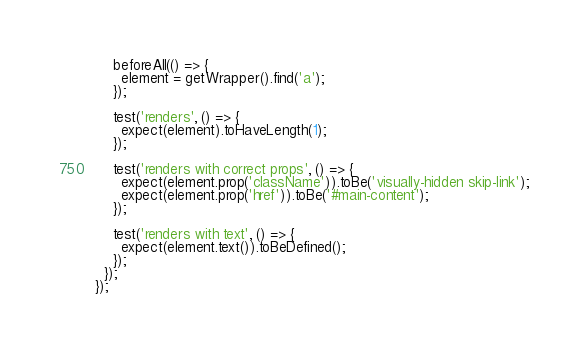<code> <loc_0><loc_0><loc_500><loc_500><_JavaScript_>    beforeAll(() => {
      element = getWrapper().find('a');
    });

    test('renders', () => {
      expect(element).toHaveLength(1);
    });

    test('renders with correct props', () => {
      expect(element.prop('className')).toBe('visually-hidden skip-link');
      expect(element.prop('href')).toBe('#main-content');
    });

    test('renders with text', () => {
      expect(element.text()).toBeDefined();
    });
  });
});
</code> 